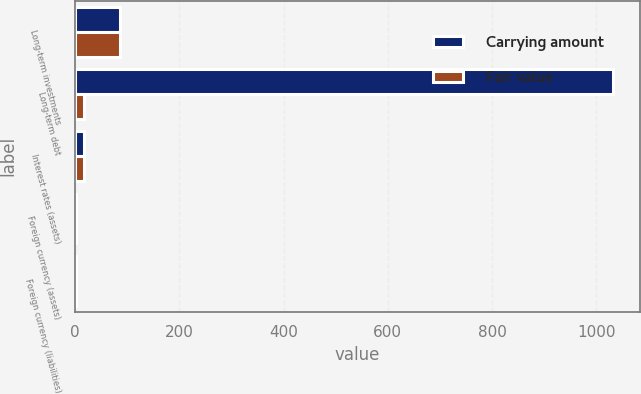Convert chart to OTSL. <chart><loc_0><loc_0><loc_500><loc_500><stacked_bar_chart><ecel><fcel>Long-term investments<fcel>Long-term debt<fcel>Interest rates (assets)<fcel>Foreign currency (assets)<fcel>Foreign currency (liabilities)<nl><fcel>Carrying amount<fcel>86.1<fcel>1031.5<fcel>16.7<fcel>0.9<fcel>1.9<nl><fcel>Fair value<fcel>86.1<fcel>16.7<fcel>16.7<fcel>0.9<fcel>1.9<nl></chart> 